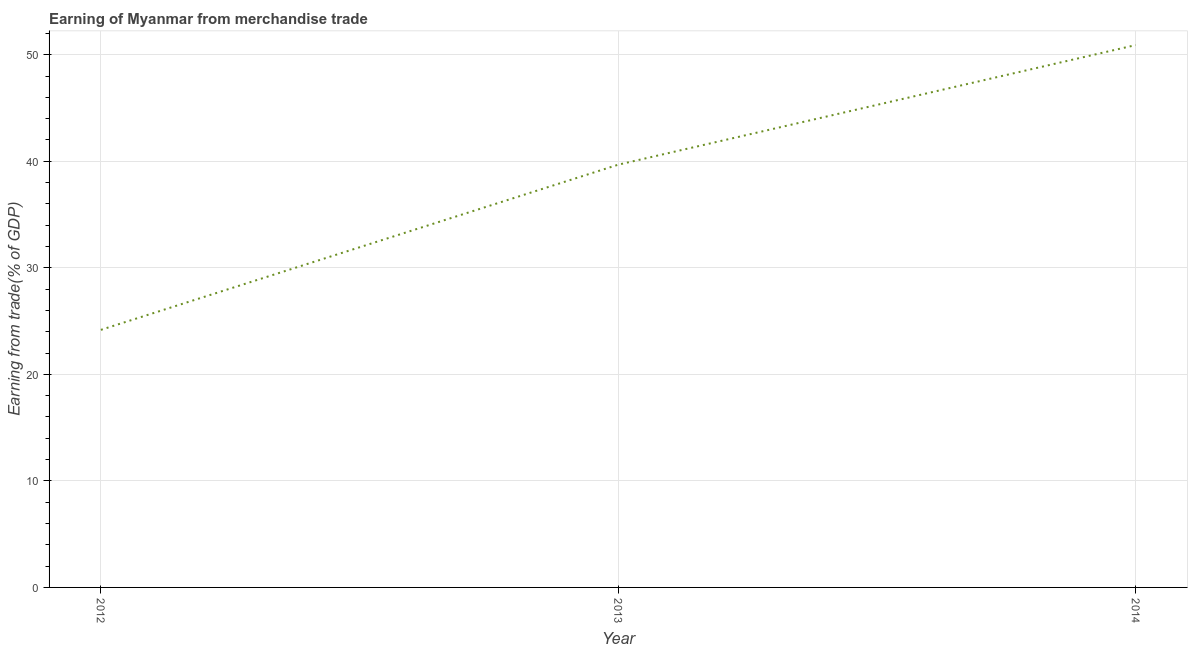What is the earning from merchandise trade in 2013?
Your response must be concise. 39.68. Across all years, what is the maximum earning from merchandise trade?
Your answer should be compact. 50.91. Across all years, what is the minimum earning from merchandise trade?
Give a very brief answer. 24.18. In which year was the earning from merchandise trade minimum?
Your answer should be very brief. 2012. What is the sum of the earning from merchandise trade?
Keep it short and to the point. 114.77. What is the difference between the earning from merchandise trade in 2012 and 2014?
Provide a succinct answer. -26.73. What is the average earning from merchandise trade per year?
Offer a terse response. 38.26. What is the median earning from merchandise trade?
Your response must be concise. 39.68. In how many years, is the earning from merchandise trade greater than 40 %?
Your response must be concise. 1. What is the ratio of the earning from merchandise trade in 2012 to that in 2013?
Your response must be concise. 0.61. Is the earning from merchandise trade in 2012 less than that in 2013?
Provide a succinct answer. Yes. What is the difference between the highest and the second highest earning from merchandise trade?
Your answer should be very brief. 11.23. Is the sum of the earning from merchandise trade in 2012 and 2014 greater than the maximum earning from merchandise trade across all years?
Keep it short and to the point. Yes. What is the difference between the highest and the lowest earning from merchandise trade?
Provide a short and direct response. 26.73. In how many years, is the earning from merchandise trade greater than the average earning from merchandise trade taken over all years?
Give a very brief answer. 2. Does the earning from merchandise trade monotonically increase over the years?
Provide a succinct answer. Yes. How many years are there in the graph?
Offer a terse response. 3. Are the values on the major ticks of Y-axis written in scientific E-notation?
Your response must be concise. No. What is the title of the graph?
Your response must be concise. Earning of Myanmar from merchandise trade. What is the label or title of the Y-axis?
Your answer should be very brief. Earning from trade(% of GDP). What is the Earning from trade(% of GDP) of 2012?
Provide a short and direct response. 24.18. What is the Earning from trade(% of GDP) in 2013?
Make the answer very short. 39.68. What is the Earning from trade(% of GDP) in 2014?
Offer a very short reply. 50.91. What is the difference between the Earning from trade(% of GDP) in 2012 and 2013?
Keep it short and to the point. -15.51. What is the difference between the Earning from trade(% of GDP) in 2012 and 2014?
Give a very brief answer. -26.73. What is the difference between the Earning from trade(% of GDP) in 2013 and 2014?
Your answer should be very brief. -11.23. What is the ratio of the Earning from trade(% of GDP) in 2012 to that in 2013?
Offer a very short reply. 0.61. What is the ratio of the Earning from trade(% of GDP) in 2012 to that in 2014?
Provide a short and direct response. 0.47. What is the ratio of the Earning from trade(% of GDP) in 2013 to that in 2014?
Keep it short and to the point. 0.78. 